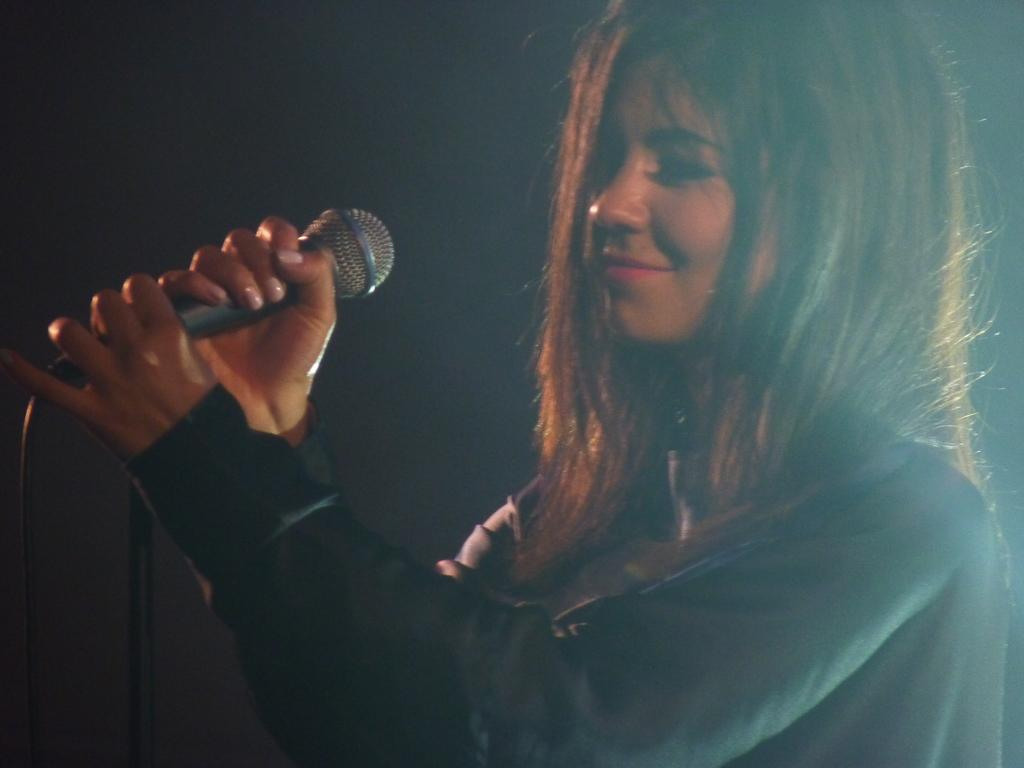Who is the main subject in the image? There is a woman in the image. What is the woman doing in the image? The woman is smiling and holding a mic with her hands. What can be observed about the background of the image? The background of the image is dark. What type of music is the woman writing in the image? There is no indication in the image that the woman is writing music or any other form of content. 